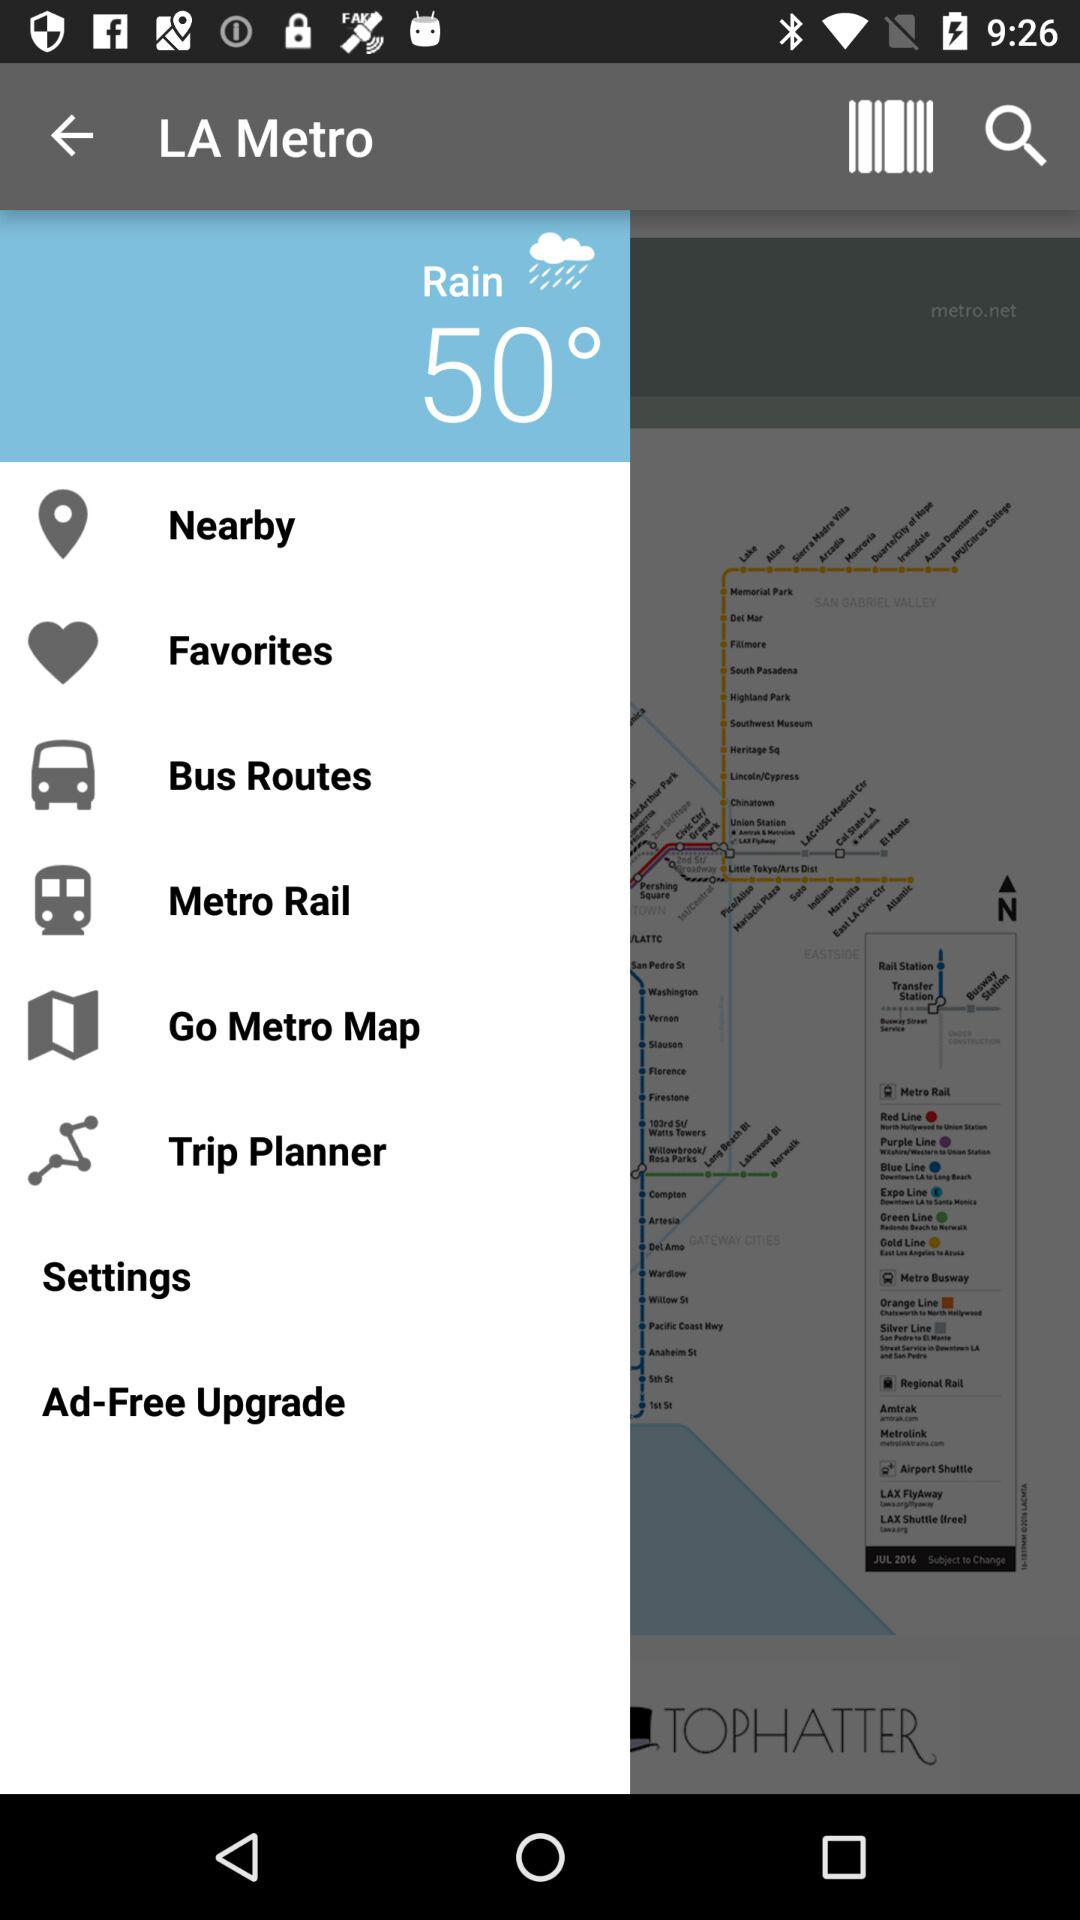What is the temperature? The temperature is 50°. 